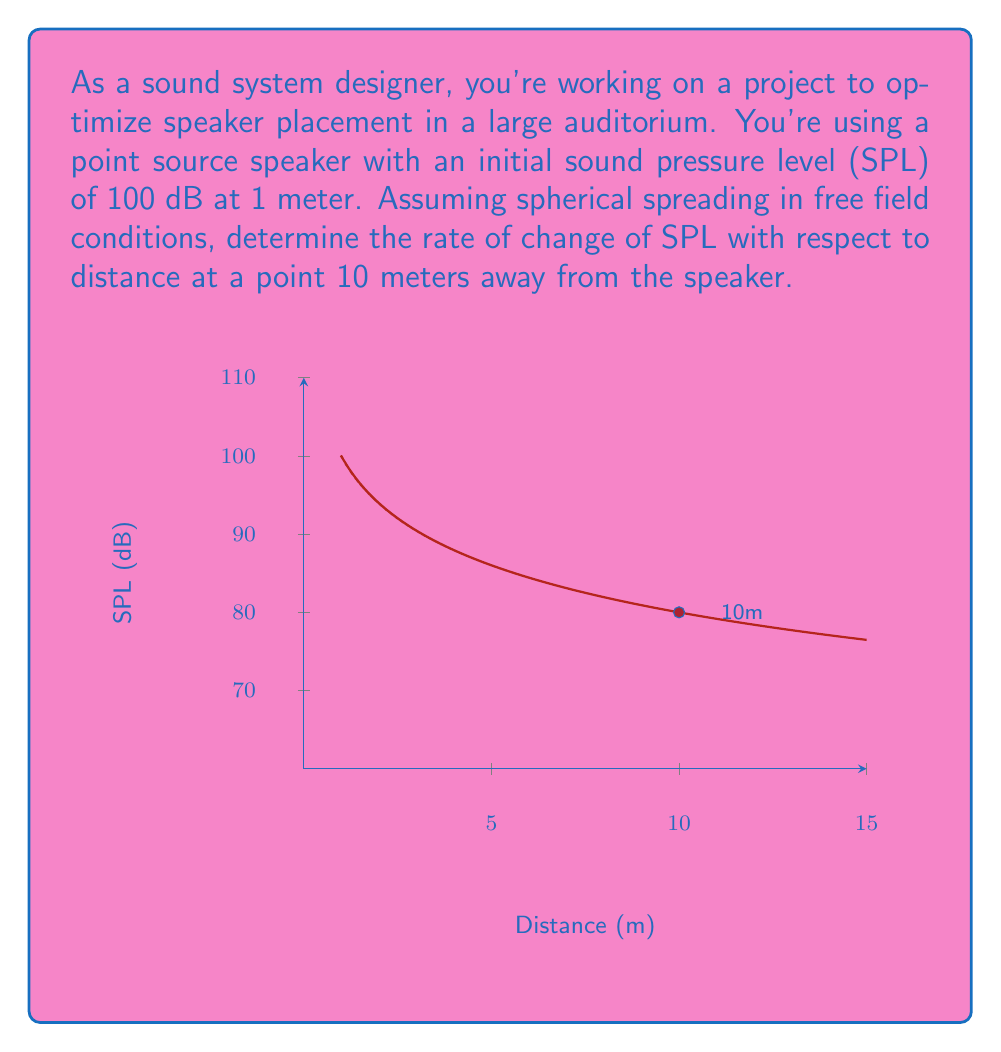Can you solve this math problem? To solve this problem, we'll follow these steps:

1) The sound pressure level (SPL) from a point source in free field conditions follows the inverse square law. The equation for SPL as a function of distance is:

   $$ SPL(r) = SPL_0 - 20 \log_{10}(\frac{r}{r_0}) $$

   Where $SPL_0$ is the initial SPL at reference distance $r_0$.

2) In this case, $SPL_0 = 100$ dB and $r_0 = 1$ m. So our equation becomes:

   $$ SPL(r) = 100 - 20 \log_{10}(r) $$

3) To find the rate of change, we need to differentiate this equation with respect to r:

   $$ \frac{d}{dr}SPL(r) = \frac{d}{dr}(100 - 20 \log_{10}(r)) $$

4) Using the chain rule:

   $$ \frac{d}{dr}SPL(r) = -20 \cdot \frac{d}{dr}\log_{10}(r) = -20 \cdot \frac{1}{r \ln(10)} $$

5) Now we have a general equation for the rate of change of SPL with respect to distance. To find the rate at 10 meters, we substitute r = 10:

   $$ \left.\frac{d}{dr}SPL(r)\right|_{r=10} = -\frac{20}{10 \ln(10)} = -\frac{2}{\ln(10)} \approx -0.8686 $$

6) The negative sign indicates that SPL decreases as distance increases.
Answer: $-\frac{2}{\ln(10)}$ dB/m or approximately -0.8686 dB/m 